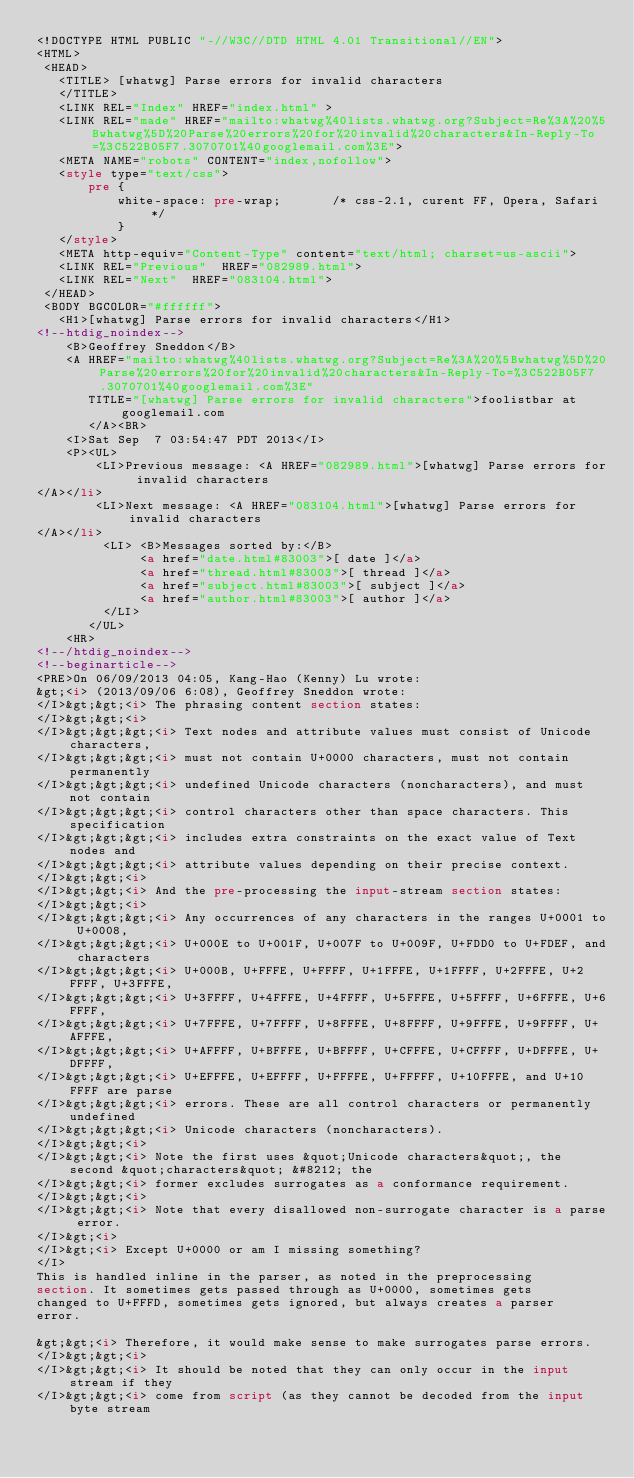<code> <loc_0><loc_0><loc_500><loc_500><_HTML_><!DOCTYPE HTML PUBLIC "-//W3C//DTD HTML 4.01 Transitional//EN">
<HTML>
 <HEAD>
   <TITLE> [whatwg] Parse errors for invalid characters
   </TITLE>
   <LINK REL="Index" HREF="index.html" >
   <LINK REL="made" HREF="mailto:whatwg%40lists.whatwg.org?Subject=Re%3A%20%5Bwhatwg%5D%20Parse%20errors%20for%20invalid%20characters&In-Reply-To=%3C522B05F7.3070701%40googlemail.com%3E">
   <META NAME="robots" CONTENT="index,nofollow">
   <style type="text/css">
       pre {
           white-space: pre-wrap;       /* css-2.1, curent FF, Opera, Safari */
           }
   </style>
   <META http-equiv="Content-Type" content="text/html; charset=us-ascii">
   <LINK REL="Previous"  HREF="082989.html">
   <LINK REL="Next"  HREF="083104.html">
 </HEAD>
 <BODY BGCOLOR="#ffffff">
   <H1>[whatwg] Parse errors for invalid characters</H1>
<!--htdig_noindex-->
    <B>Geoffrey Sneddon</B> 
    <A HREF="mailto:whatwg%40lists.whatwg.org?Subject=Re%3A%20%5Bwhatwg%5D%20Parse%20errors%20for%20invalid%20characters&In-Reply-To=%3C522B05F7.3070701%40googlemail.com%3E"
       TITLE="[whatwg] Parse errors for invalid characters">foolistbar at googlemail.com
       </A><BR>
    <I>Sat Sep  7 03:54:47 PDT 2013</I>
    <P><UL>
        <LI>Previous message: <A HREF="082989.html">[whatwg] Parse errors for invalid characters
</A></li>
        <LI>Next message: <A HREF="083104.html">[whatwg] Parse errors for invalid characters
</A></li>
         <LI> <B>Messages sorted by:</B> 
              <a href="date.html#83003">[ date ]</a>
              <a href="thread.html#83003">[ thread ]</a>
              <a href="subject.html#83003">[ subject ]</a>
              <a href="author.html#83003">[ author ]</a>
         </LI>
       </UL>
    <HR>  
<!--/htdig_noindex-->
<!--beginarticle-->
<PRE>On 06/09/2013 04:05, Kang-Hao (Kenny) Lu wrote:
&gt;<i> (2013/09/06 6:08), Geoffrey Sneddon wrote:
</I>&gt;&gt;<i> The phrasing content section states:
</I>&gt;&gt;<i>
</I>&gt;&gt;&gt;<i> Text nodes and attribute values must consist of Unicode characters,
</I>&gt;&gt;&gt;<i> must not contain U+0000 characters, must not contain permanently
</I>&gt;&gt;&gt;<i> undefined Unicode characters (noncharacters), and must not contain
</I>&gt;&gt;&gt;<i> control characters other than space characters. This specification
</I>&gt;&gt;&gt;<i> includes extra constraints on the exact value of Text nodes and
</I>&gt;&gt;&gt;<i> attribute values depending on their precise context.
</I>&gt;&gt;<i>
</I>&gt;&gt;<i> And the pre-processing the input-stream section states:
</I>&gt;&gt;<i>
</I>&gt;&gt;&gt;<i> Any occurrences of any characters in the ranges U+0001 to U+0008,
</I>&gt;&gt;&gt;<i> U+000E to U+001F, U+007F to U+009F, U+FDD0 to U+FDEF, and characters
</I>&gt;&gt;&gt;<i> U+000B, U+FFFE, U+FFFF, U+1FFFE, U+1FFFF, U+2FFFE, U+2FFFF, U+3FFFE,
</I>&gt;&gt;&gt;<i> U+3FFFF, U+4FFFE, U+4FFFF, U+5FFFE, U+5FFFF, U+6FFFE, U+6FFFF,
</I>&gt;&gt;&gt;<i> U+7FFFE, U+7FFFF, U+8FFFE, U+8FFFF, U+9FFFE, U+9FFFF, U+AFFFE,
</I>&gt;&gt;&gt;<i> U+AFFFF, U+BFFFE, U+BFFFF, U+CFFFE, U+CFFFF, U+DFFFE, U+DFFFF,
</I>&gt;&gt;&gt;<i> U+EFFFE, U+EFFFF, U+FFFFE, U+FFFFF, U+10FFFE, and U+10FFFF are parse
</I>&gt;&gt;&gt;<i> errors. These are all control characters or permanently undefined
</I>&gt;&gt;&gt;<i> Unicode characters (noncharacters).
</I>&gt;&gt;<i>
</I>&gt;&gt;<i> Note the first uses &quot;Unicode characters&quot;, the second &quot;characters&quot; &#8212; the
</I>&gt;&gt;<i> former excludes surrogates as a conformance requirement.
</I>&gt;&gt;<i>
</I>&gt;&gt;<i> Note that every disallowed non-surrogate character is a parse error.
</I>&gt;<i>
</I>&gt;<i> Except U+0000 or am I missing something?
</I>
This is handled inline in the parser, as noted in the preprocessing 
section. It sometimes gets passed through as U+0000, sometimes gets 
changed to U+FFFD, sometimes gets ignored, but always creates a parser 
error.

&gt;&gt;<i> Therefore, it would make sense to make surrogates parse errors.
</I>&gt;&gt;<i>
</I>&gt;&gt;<i> It should be noted that they can only occur in the input stream if they
</I>&gt;&gt;<i> come from script (as they cannot be decoded from the input byte stream</code> 